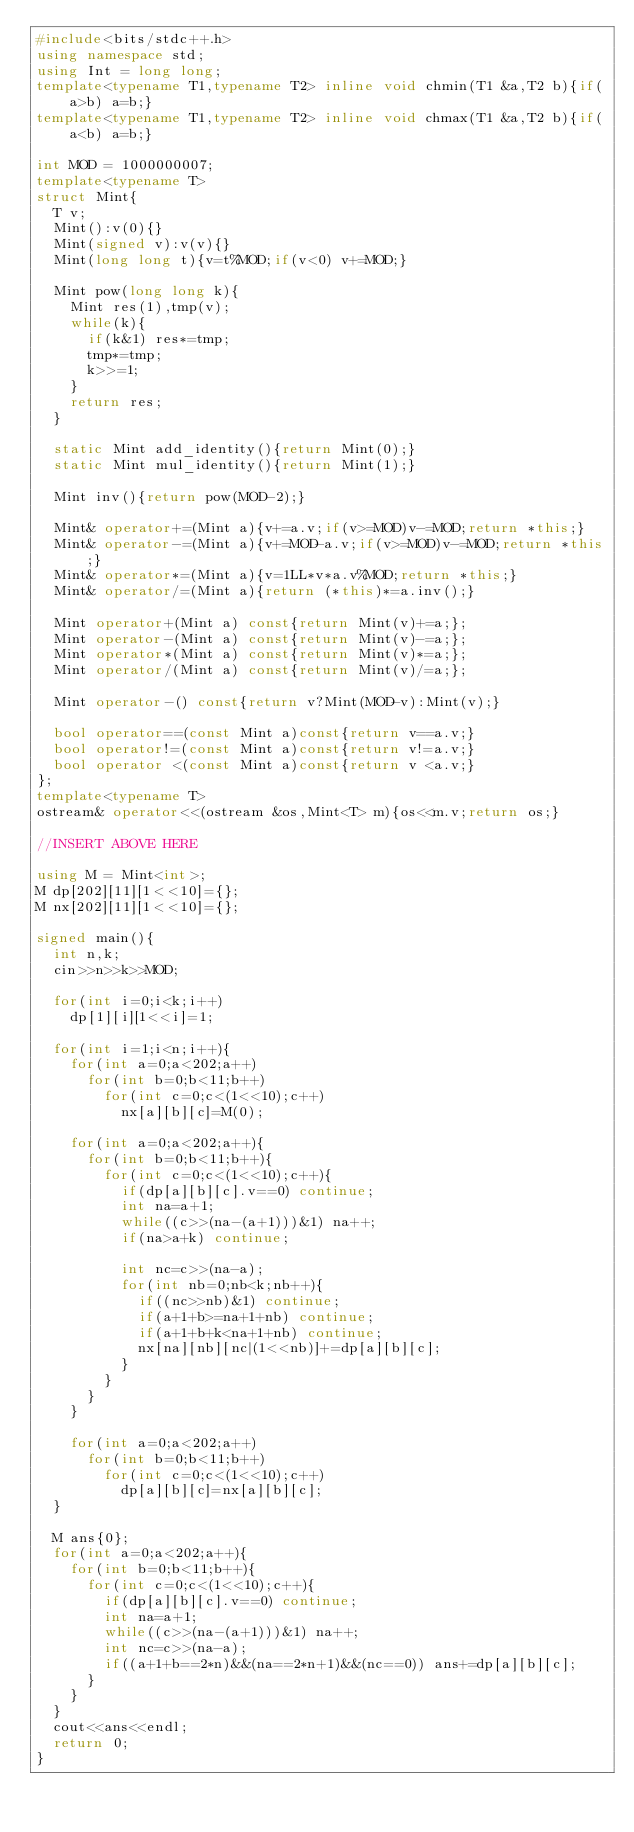Convert code to text. <code><loc_0><loc_0><loc_500><loc_500><_C++_>#include<bits/stdc++.h>
using namespace std;
using Int = long long;
template<typename T1,typename T2> inline void chmin(T1 &a,T2 b){if(a>b) a=b;}
template<typename T1,typename T2> inline void chmax(T1 &a,T2 b){if(a<b) a=b;}

int MOD = 1000000007;
template<typename T>
struct Mint{
  T v;
  Mint():v(0){}
  Mint(signed v):v(v){}
  Mint(long long t){v=t%MOD;if(v<0) v+=MOD;}

  Mint pow(long long k){
    Mint res(1),tmp(v);
    while(k){
      if(k&1) res*=tmp;
      tmp*=tmp;
      k>>=1;
    }
    return res;
  }

  static Mint add_identity(){return Mint(0);}
  static Mint mul_identity(){return Mint(1);}

  Mint inv(){return pow(MOD-2);}

  Mint& operator+=(Mint a){v+=a.v;if(v>=MOD)v-=MOD;return *this;}
  Mint& operator-=(Mint a){v+=MOD-a.v;if(v>=MOD)v-=MOD;return *this;}
  Mint& operator*=(Mint a){v=1LL*v*a.v%MOD;return *this;}
  Mint& operator/=(Mint a){return (*this)*=a.inv();}

  Mint operator+(Mint a) const{return Mint(v)+=a;};
  Mint operator-(Mint a) const{return Mint(v)-=a;};
  Mint operator*(Mint a) const{return Mint(v)*=a;};
  Mint operator/(Mint a) const{return Mint(v)/=a;};

  Mint operator-() const{return v?Mint(MOD-v):Mint(v);}

  bool operator==(const Mint a)const{return v==a.v;}
  bool operator!=(const Mint a)const{return v!=a.v;}
  bool operator <(const Mint a)const{return v <a.v;}
};
template<typename T>
ostream& operator<<(ostream &os,Mint<T> m){os<<m.v;return os;}

//INSERT ABOVE HERE

using M = Mint<int>;
M dp[202][11][1<<10]={};
M nx[202][11][1<<10]={};

signed main(){
  int n,k;
  cin>>n>>k>>MOD;

  for(int i=0;i<k;i++)
    dp[1][i][1<<i]=1;

  for(int i=1;i<n;i++){
    for(int a=0;a<202;a++)
      for(int b=0;b<11;b++)
        for(int c=0;c<(1<<10);c++)
          nx[a][b][c]=M(0);

    for(int a=0;a<202;a++){
      for(int b=0;b<11;b++){
        for(int c=0;c<(1<<10);c++){
          if(dp[a][b][c].v==0) continue;
          int na=a+1;
          while((c>>(na-(a+1)))&1) na++;
          if(na>a+k) continue;

          int nc=c>>(na-a);
          for(int nb=0;nb<k;nb++){
            if((nc>>nb)&1) continue;
            if(a+1+b>=na+1+nb) continue;
            if(a+1+b+k<na+1+nb) continue;
            nx[na][nb][nc|(1<<nb)]+=dp[a][b][c];
          }
        }
      }
    }

    for(int a=0;a<202;a++)
      for(int b=0;b<11;b++)
        for(int c=0;c<(1<<10);c++)
          dp[a][b][c]=nx[a][b][c];
  }

  M ans{0};
  for(int a=0;a<202;a++){
    for(int b=0;b<11;b++){
      for(int c=0;c<(1<<10);c++){
        if(dp[a][b][c].v==0) continue;
        int na=a+1;
        while((c>>(na-(a+1)))&1) na++;
        int nc=c>>(na-a);
        if((a+1+b==2*n)&&(na==2*n+1)&&(nc==0)) ans+=dp[a][b][c];
      }
    }
  }
  cout<<ans<<endl;
  return 0;
}

</code> 